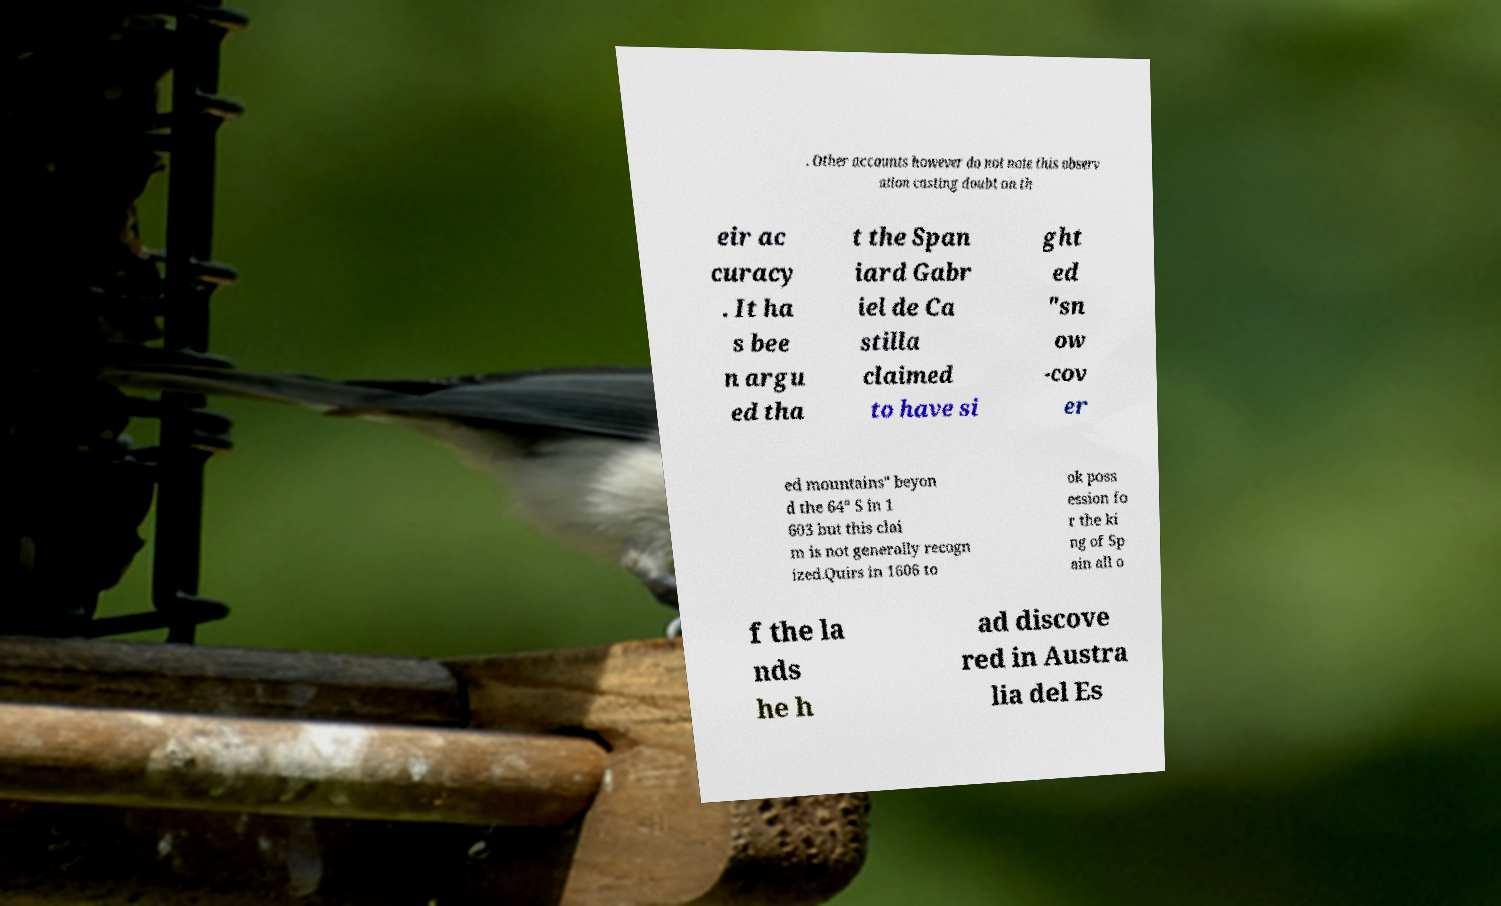Please identify and transcribe the text found in this image. . Other accounts however do not note this observ ation casting doubt on th eir ac curacy . It ha s bee n argu ed tha t the Span iard Gabr iel de Ca stilla claimed to have si ght ed "sn ow -cov er ed mountains" beyon d the 64° S in 1 603 but this clai m is not generally recogn ized.Quirs in 1606 to ok poss ession fo r the ki ng of Sp ain all o f the la nds he h ad discove red in Austra lia del Es 